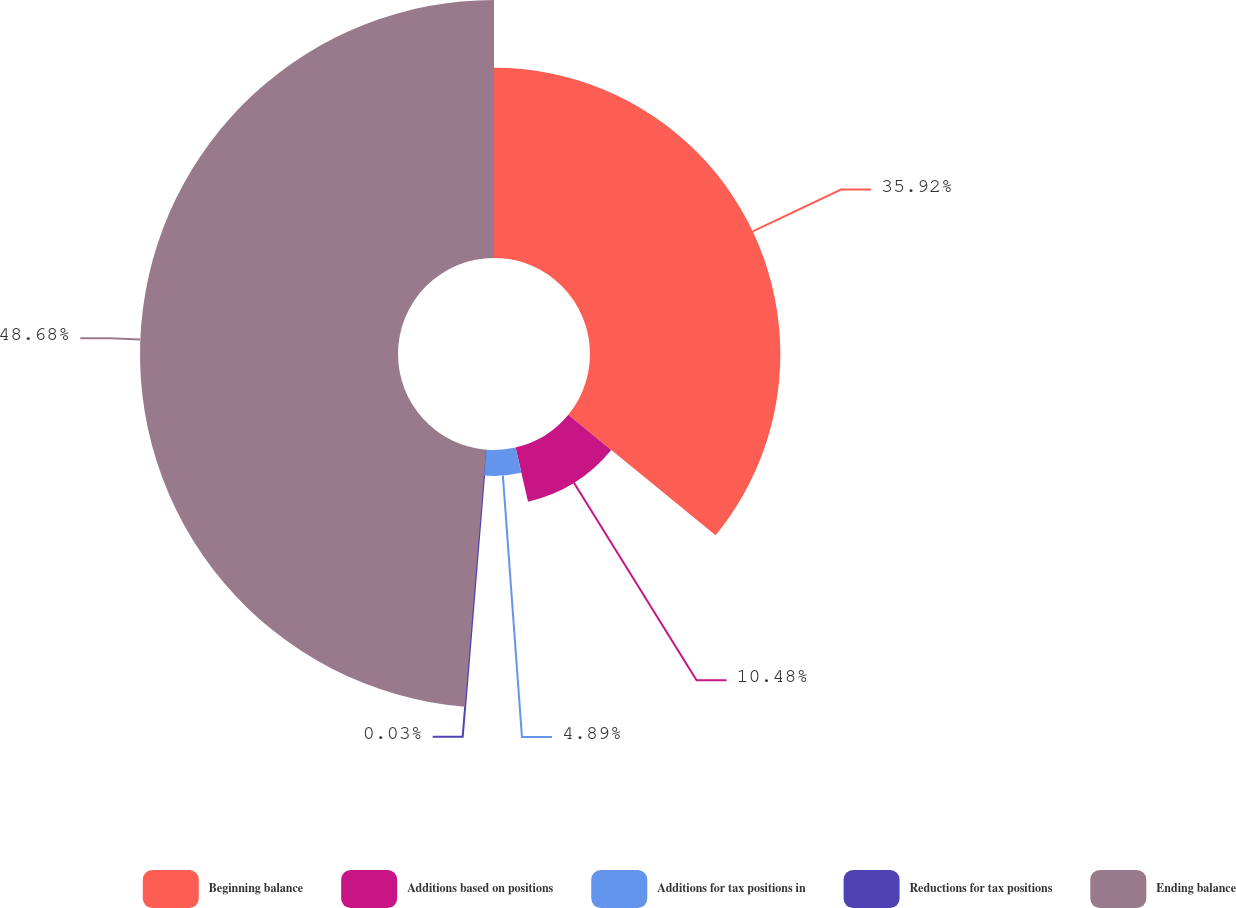Convert chart. <chart><loc_0><loc_0><loc_500><loc_500><pie_chart><fcel>Beginning balance<fcel>Additions based on positions<fcel>Additions for tax positions in<fcel>Reductions for tax positions<fcel>Ending balance<nl><fcel>35.92%<fcel>10.48%<fcel>4.89%<fcel>0.03%<fcel>48.69%<nl></chart> 